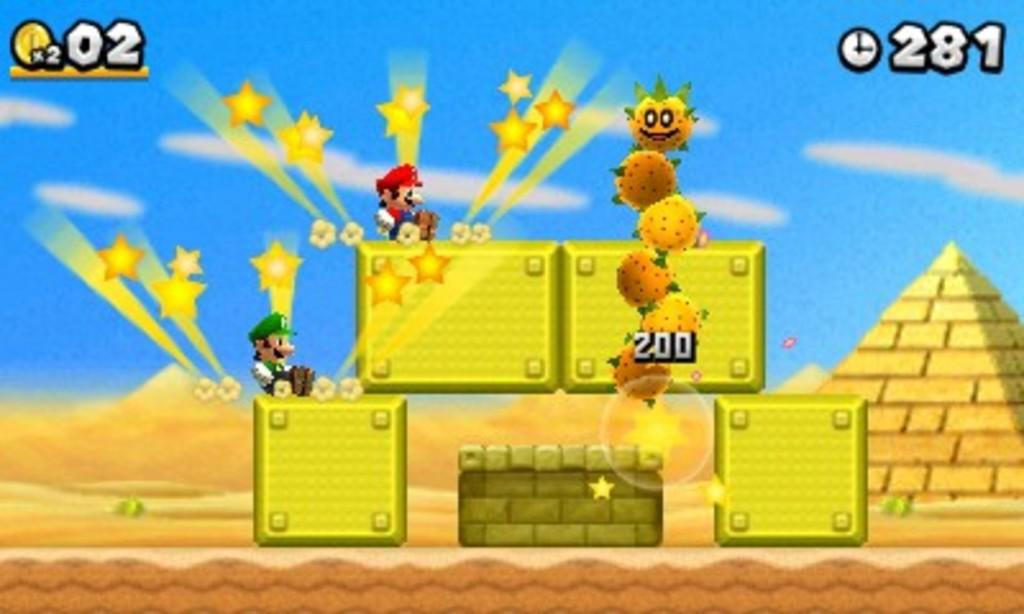What type of image is shown in the picture? The image contains a game screen. What can be seen on the game screen? The game screen depicts persons and stars. Are there any structural elements on the game screen? Yes, the game screen has walls. Are there any numerical elements on the game screen? Yes, the game screen includes numbers. Can you see a ladybug on the game screen? There is no ladybug present on the game screen; it only contains persons, stars, walls, and numbers. 